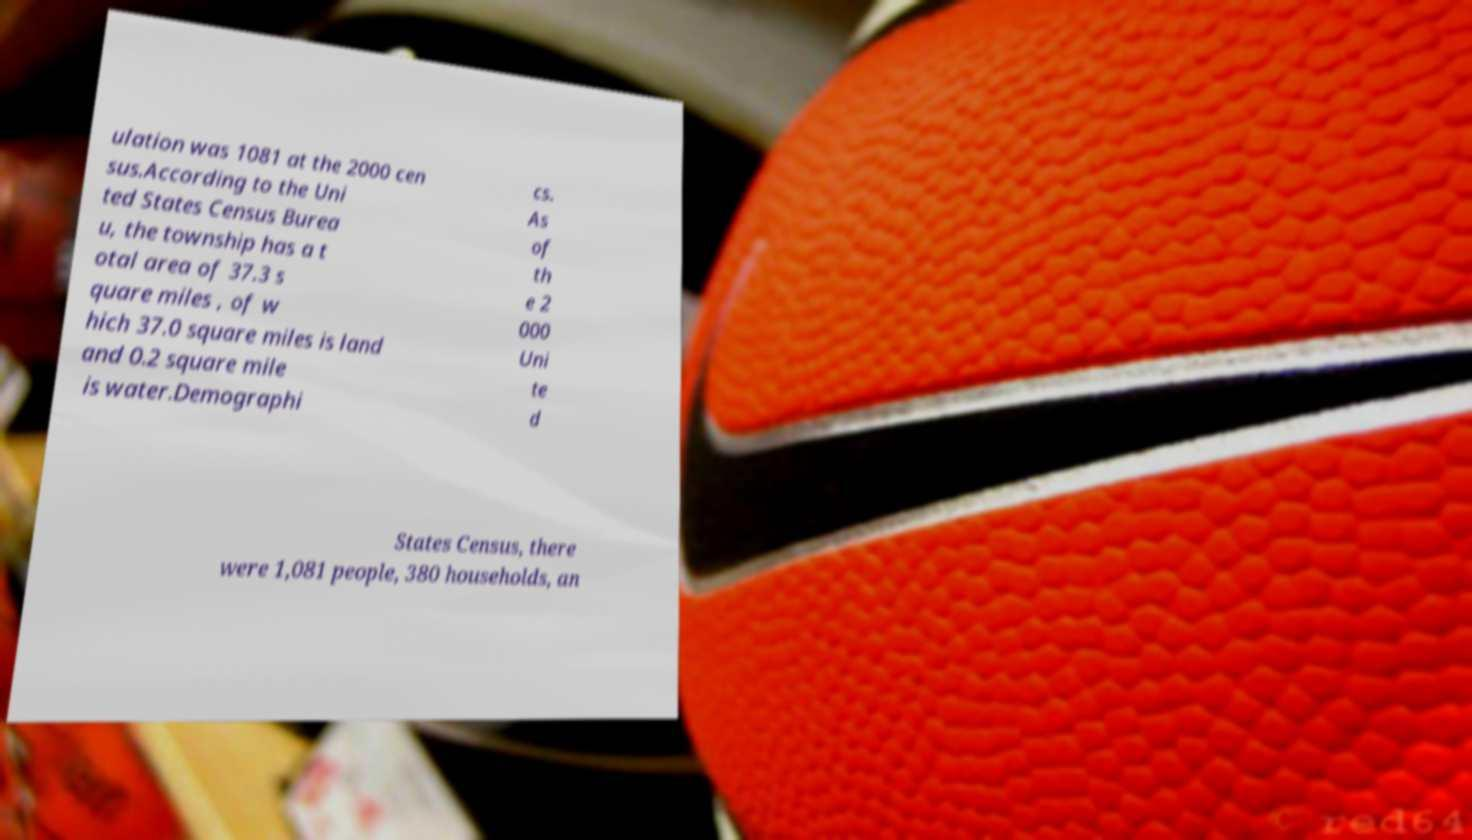For documentation purposes, I need the text within this image transcribed. Could you provide that? ulation was 1081 at the 2000 cen sus.According to the Uni ted States Census Burea u, the township has a t otal area of 37.3 s quare miles , of w hich 37.0 square miles is land and 0.2 square mile is water.Demographi cs. As of th e 2 000 Uni te d States Census, there were 1,081 people, 380 households, an 